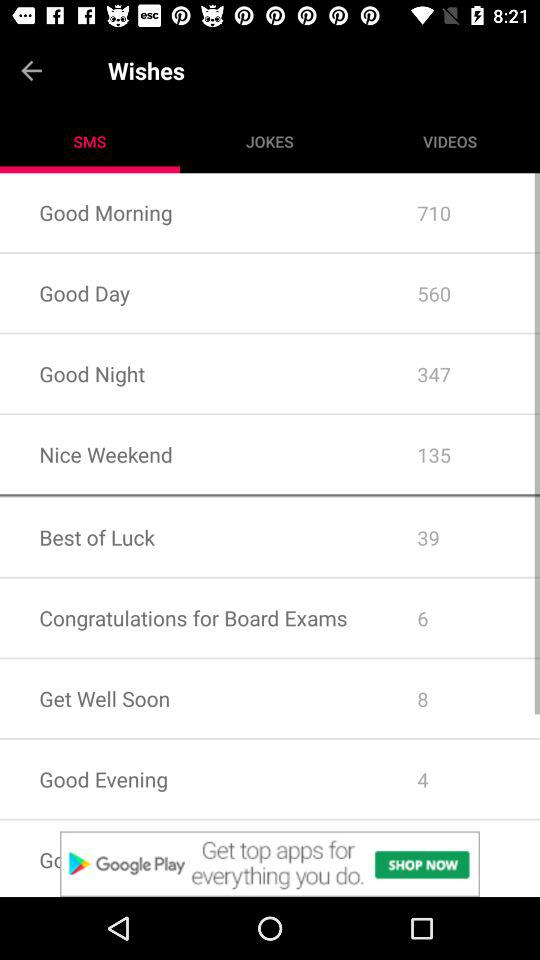How many "Get Well Soon" messages are there? There are 8 "Get Well Soon" messages. 